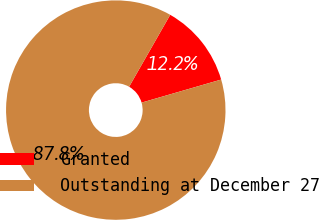Convert chart. <chart><loc_0><loc_0><loc_500><loc_500><pie_chart><fcel>Granted<fcel>Outstanding at December 27<nl><fcel>12.25%<fcel>87.75%<nl></chart> 